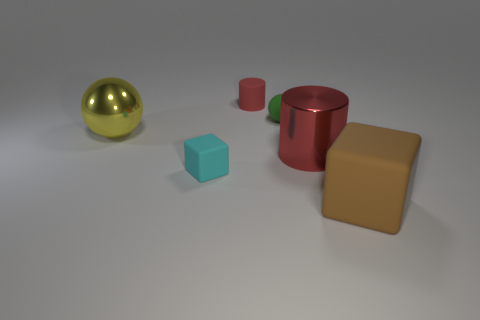What time of day does the lighting in this image suggest? The image seems to be lit with neutral, diffuse lighting that doesn't indicate a specific time of day. It's likely an indoor photo with controlled studio lighting, as there are no strong shadows or indications of natural light from a sun source. 